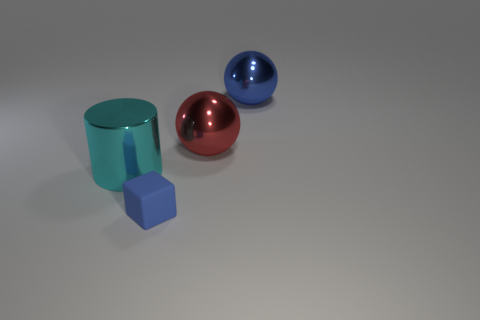Add 1 balls. How many objects exist? 5 Subtract all cubes. How many objects are left? 3 Add 2 cyan metal things. How many cyan metal things exist? 3 Subtract 0 gray cubes. How many objects are left? 4 Subtract all blue metallic balls. Subtract all red metal balls. How many objects are left? 2 Add 3 blue matte cubes. How many blue matte cubes are left? 4 